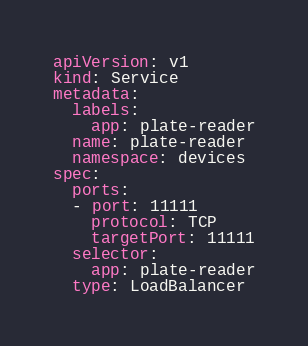<code> <loc_0><loc_0><loc_500><loc_500><_YAML_>apiVersion: v1
kind: Service
metadata:
  labels:
    app: plate-reader
  name: plate-reader
  namespace: devices
spec:
  ports:
  - port: 11111
    protocol: TCP
    targetPort: 11111
  selector:
    app: plate-reader
  type: LoadBalancer
</code> 